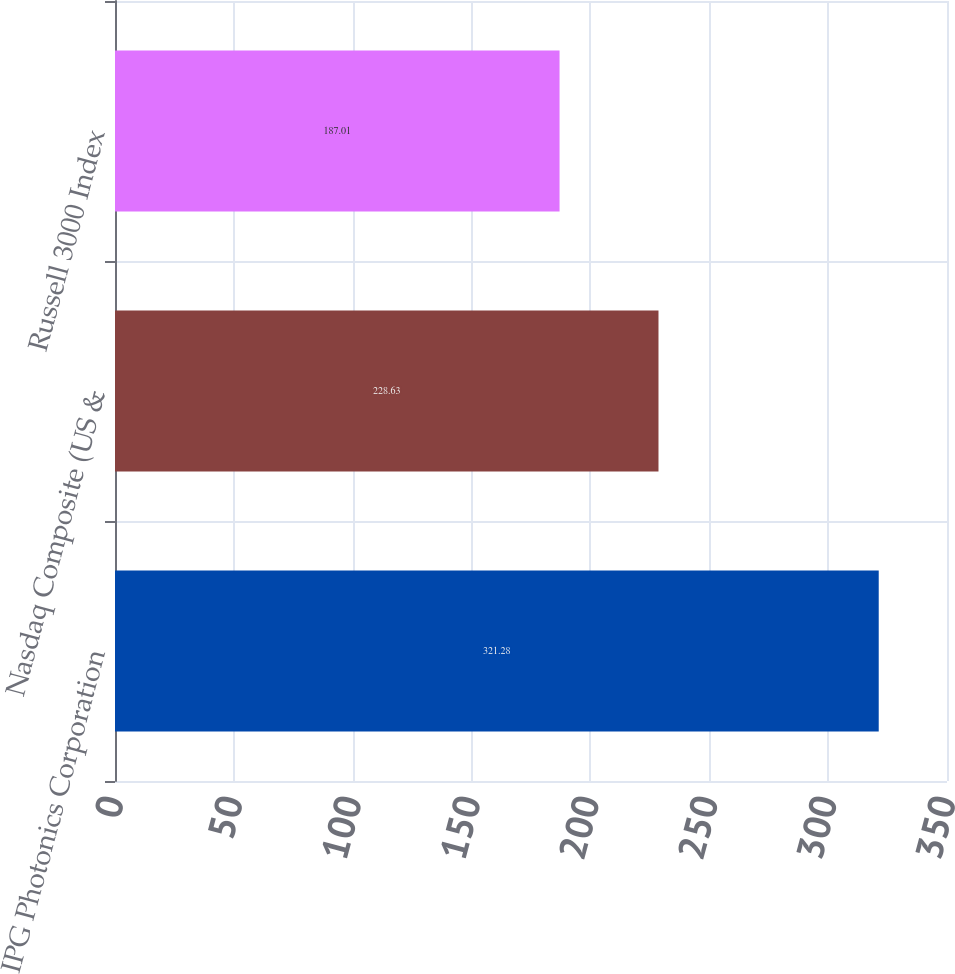<chart> <loc_0><loc_0><loc_500><loc_500><bar_chart><fcel>IPG Photonics Corporation<fcel>Nasdaq Composite (US &<fcel>Russell 3000 Index<nl><fcel>321.28<fcel>228.63<fcel>187.01<nl></chart> 